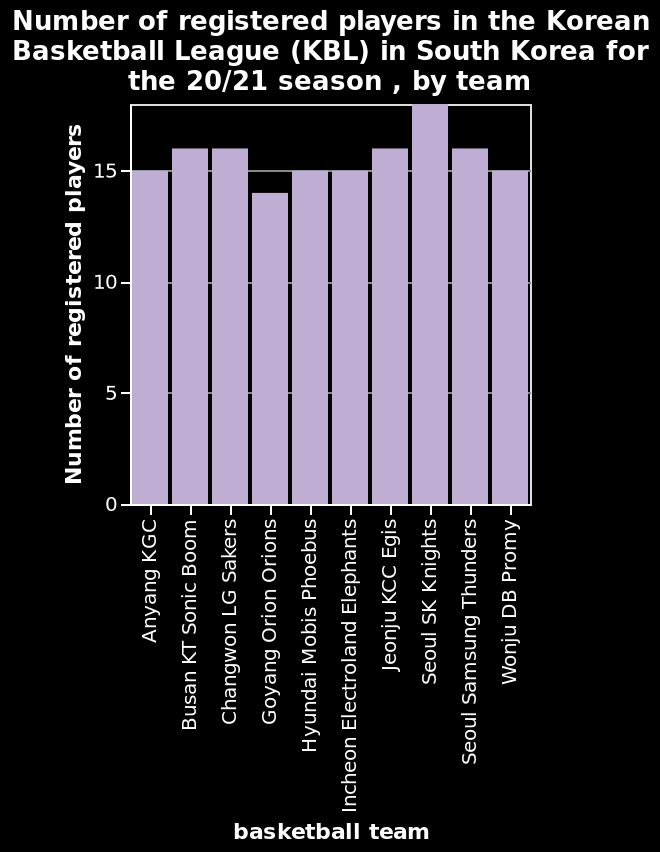<image>
What does the x-axis measure in the given bar plot?  The x-axis measures the basketball teams in the Korean Basketball League (KBL) in South Korea for the 20/21 season. What is the topic of the bar plot?  The bar plot represents the number of registered players in the Korean Basketball League (KBL) in South Korea for the 20/21 season, categorized by team. 